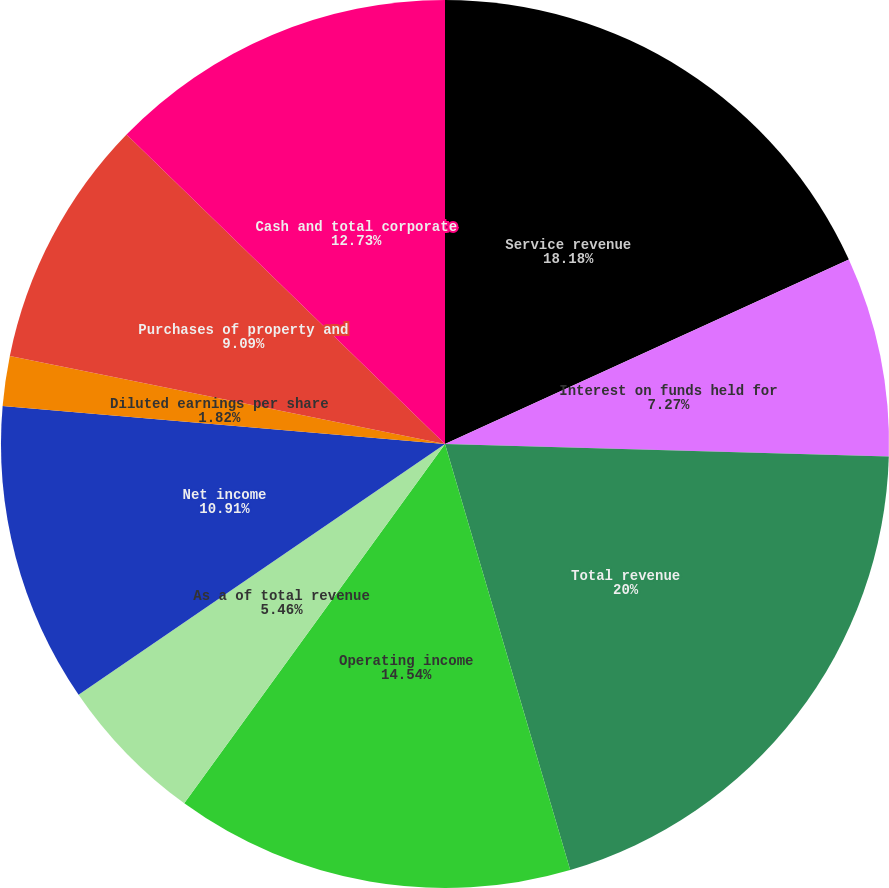<chart> <loc_0><loc_0><loc_500><loc_500><pie_chart><fcel>Service revenue<fcel>Interest on funds held for<fcel>Total revenue<fcel>Operating income<fcel>As a of total revenue<fcel>Net income<fcel>Diluted earnings per share<fcel>Cash dividends per common<fcel>Purchases of property and<fcel>Cash and total corporate<nl><fcel>18.18%<fcel>7.27%<fcel>20.0%<fcel>14.54%<fcel>5.46%<fcel>10.91%<fcel>1.82%<fcel>0.0%<fcel>9.09%<fcel>12.73%<nl></chart> 